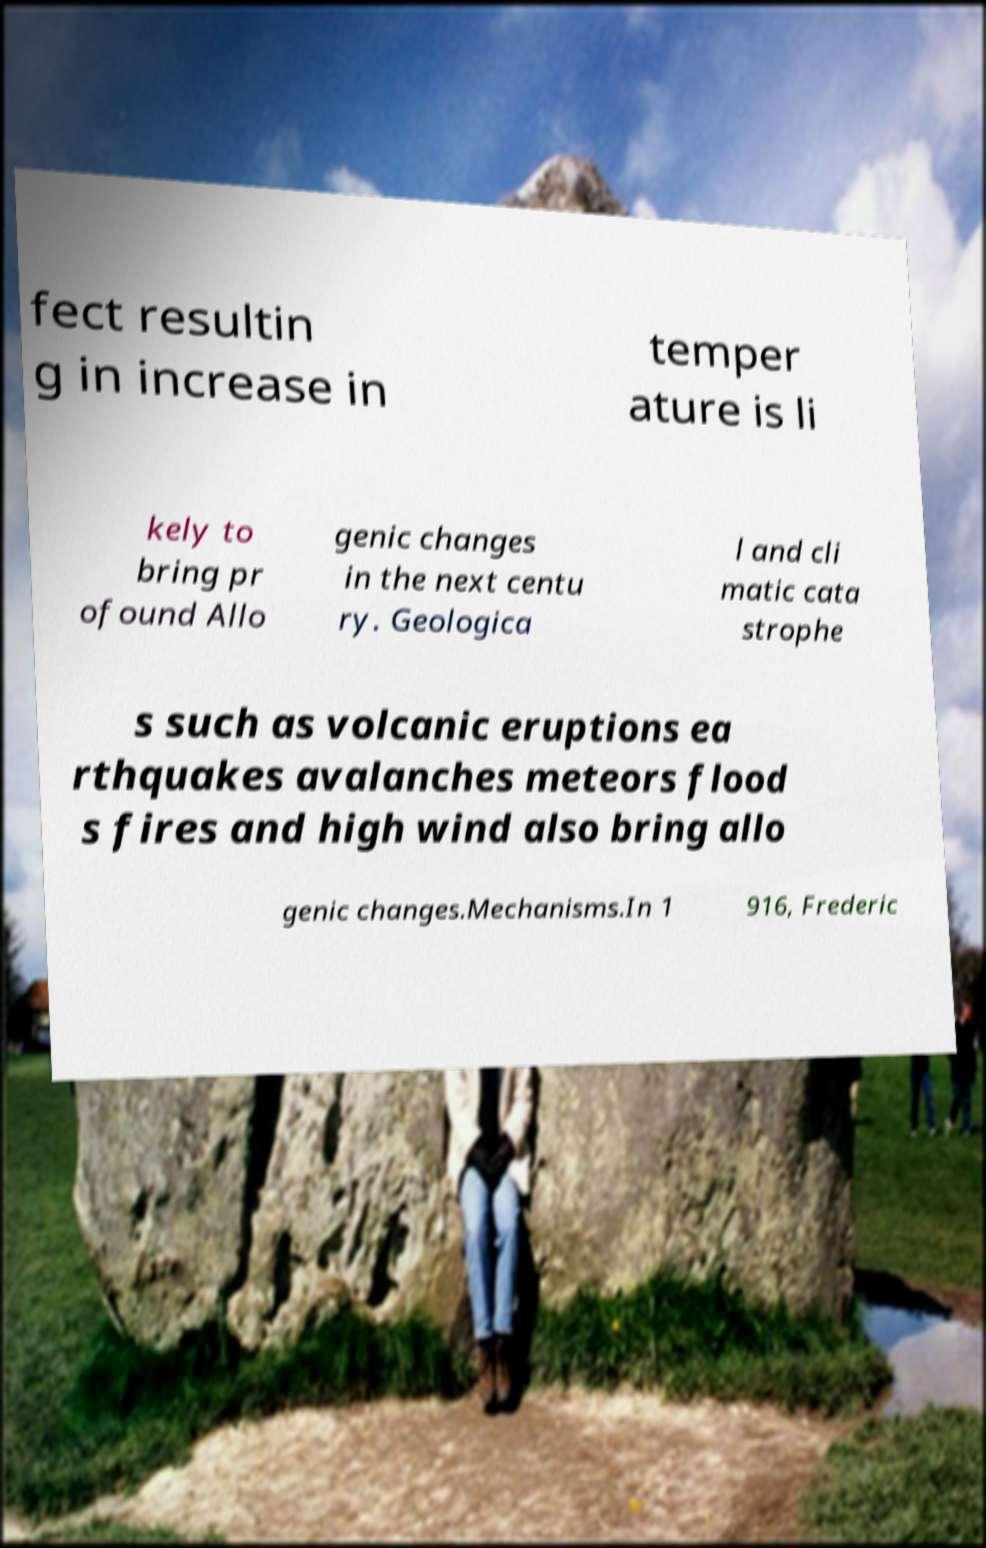Please read and relay the text visible in this image. What does it say? fect resultin g in increase in temper ature is li kely to bring pr ofound Allo genic changes in the next centu ry. Geologica l and cli matic cata strophe s such as volcanic eruptions ea rthquakes avalanches meteors flood s fires and high wind also bring allo genic changes.Mechanisms.In 1 916, Frederic 